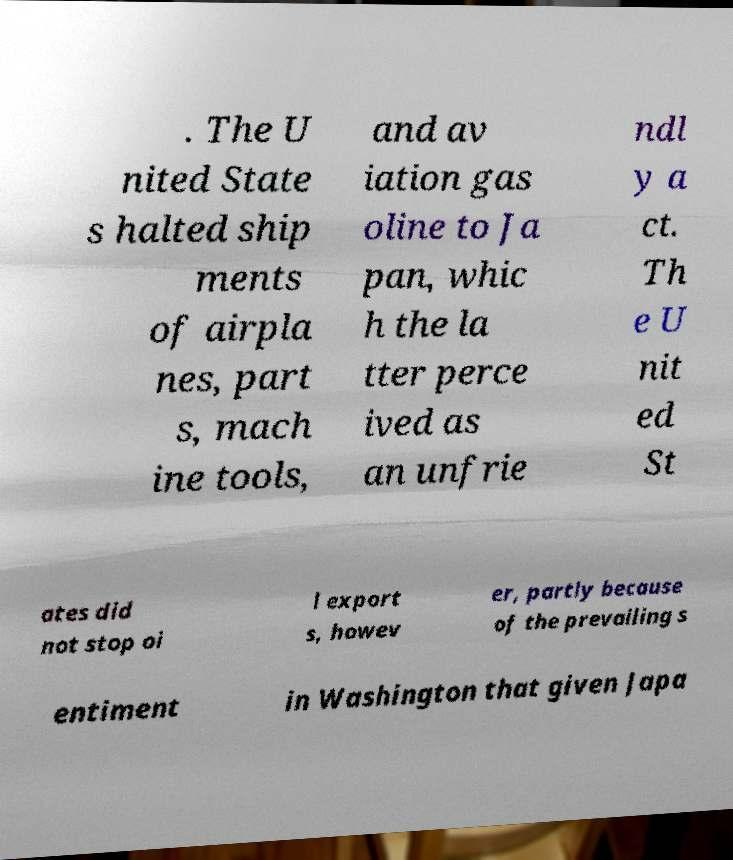Please read and relay the text visible in this image. What does it say? . The U nited State s halted ship ments of airpla nes, part s, mach ine tools, and av iation gas oline to Ja pan, whic h the la tter perce ived as an unfrie ndl y a ct. Th e U nit ed St ates did not stop oi l export s, howev er, partly because of the prevailing s entiment in Washington that given Japa 